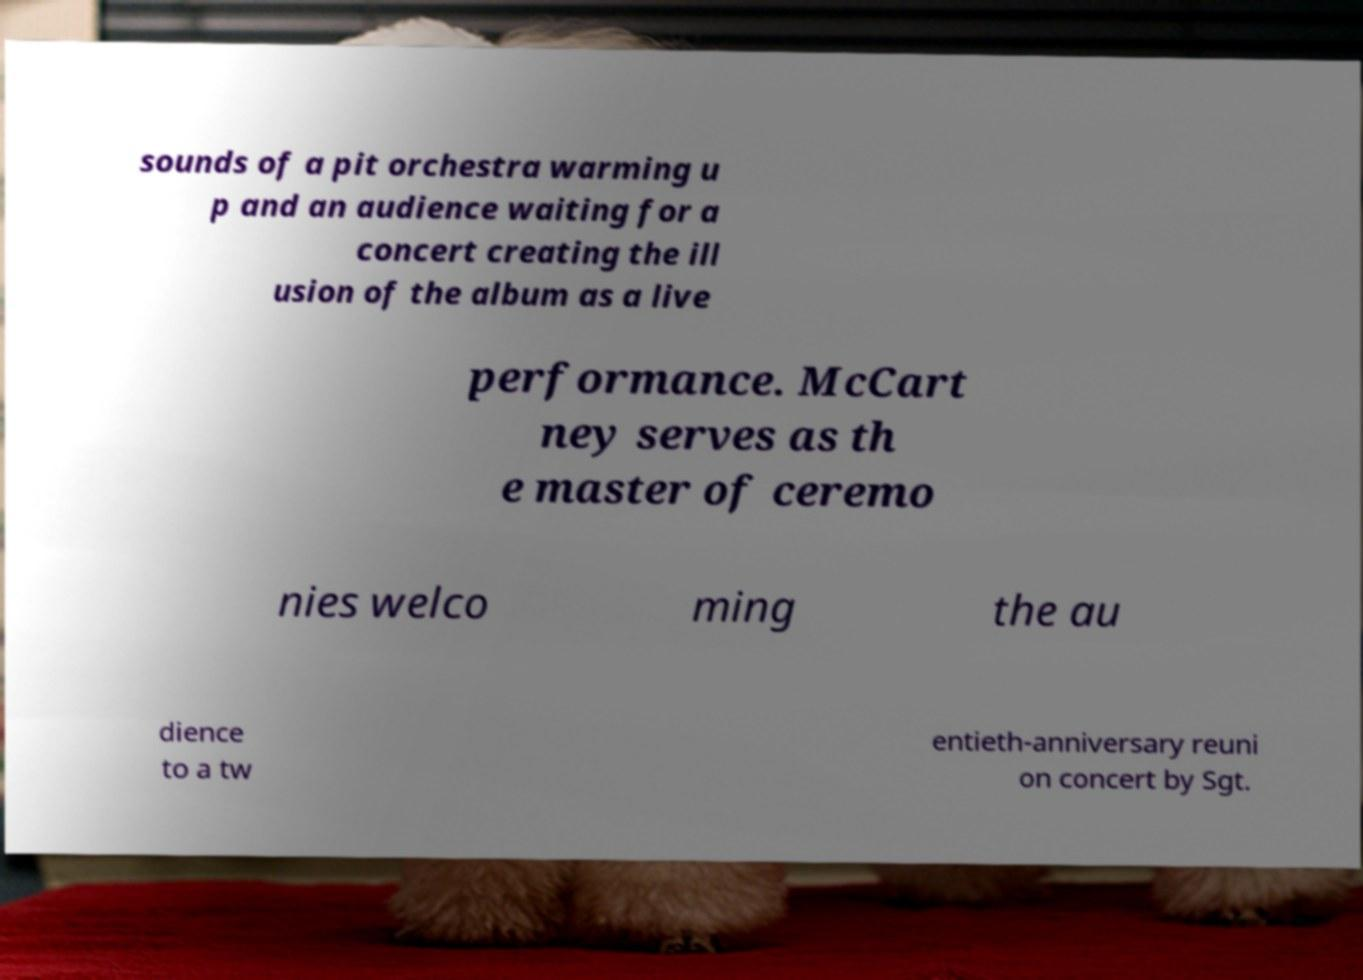I need the written content from this picture converted into text. Can you do that? sounds of a pit orchestra warming u p and an audience waiting for a concert creating the ill usion of the album as a live performance. McCart ney serves as th e master of ceremo nies welco ming the au dience to a tw entieth-anniversary reuni on concert by Sgt. 